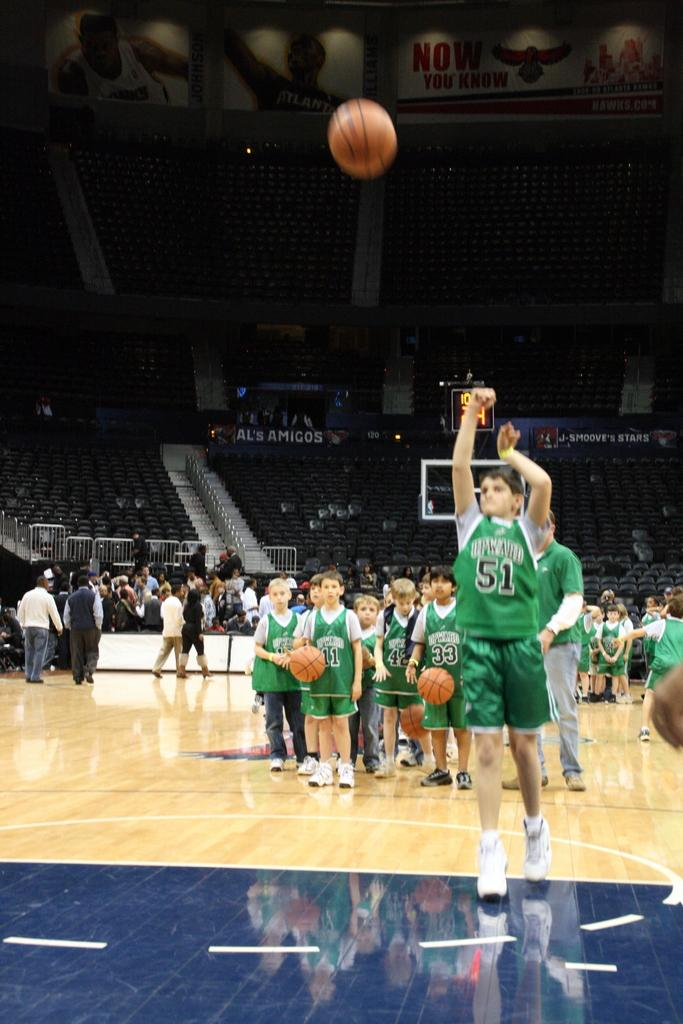Who or what can be seen in the image? There are people in the image. What objects are present in the image? There are balls, boards, and railings visible in the image. What can be seen in the background of the image? There are bleachers in the background of the image. What type of fuel is being used by the lamp in the image? There is no lamp present in the image, so it is not possible to determine what type of fuel it might use. 